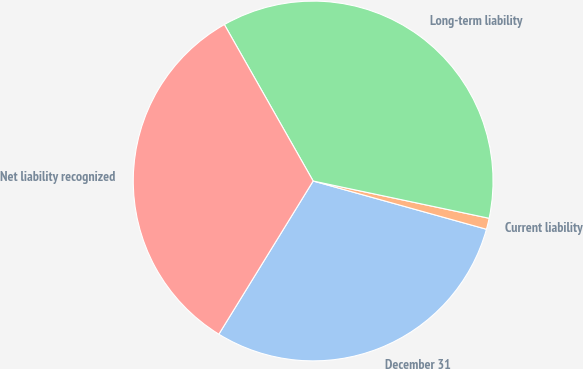<chart> <loc_0><loc_0><loc_500><loc_500><pie_chart><fcel>December 31<fcel>Current liability<fcel>Long-term liability<fcel>Net liability recognized<nl><fcel>29.46%<fcel>1.0%<fcel>36.54%<fcel>33.0%<nl></chart> 